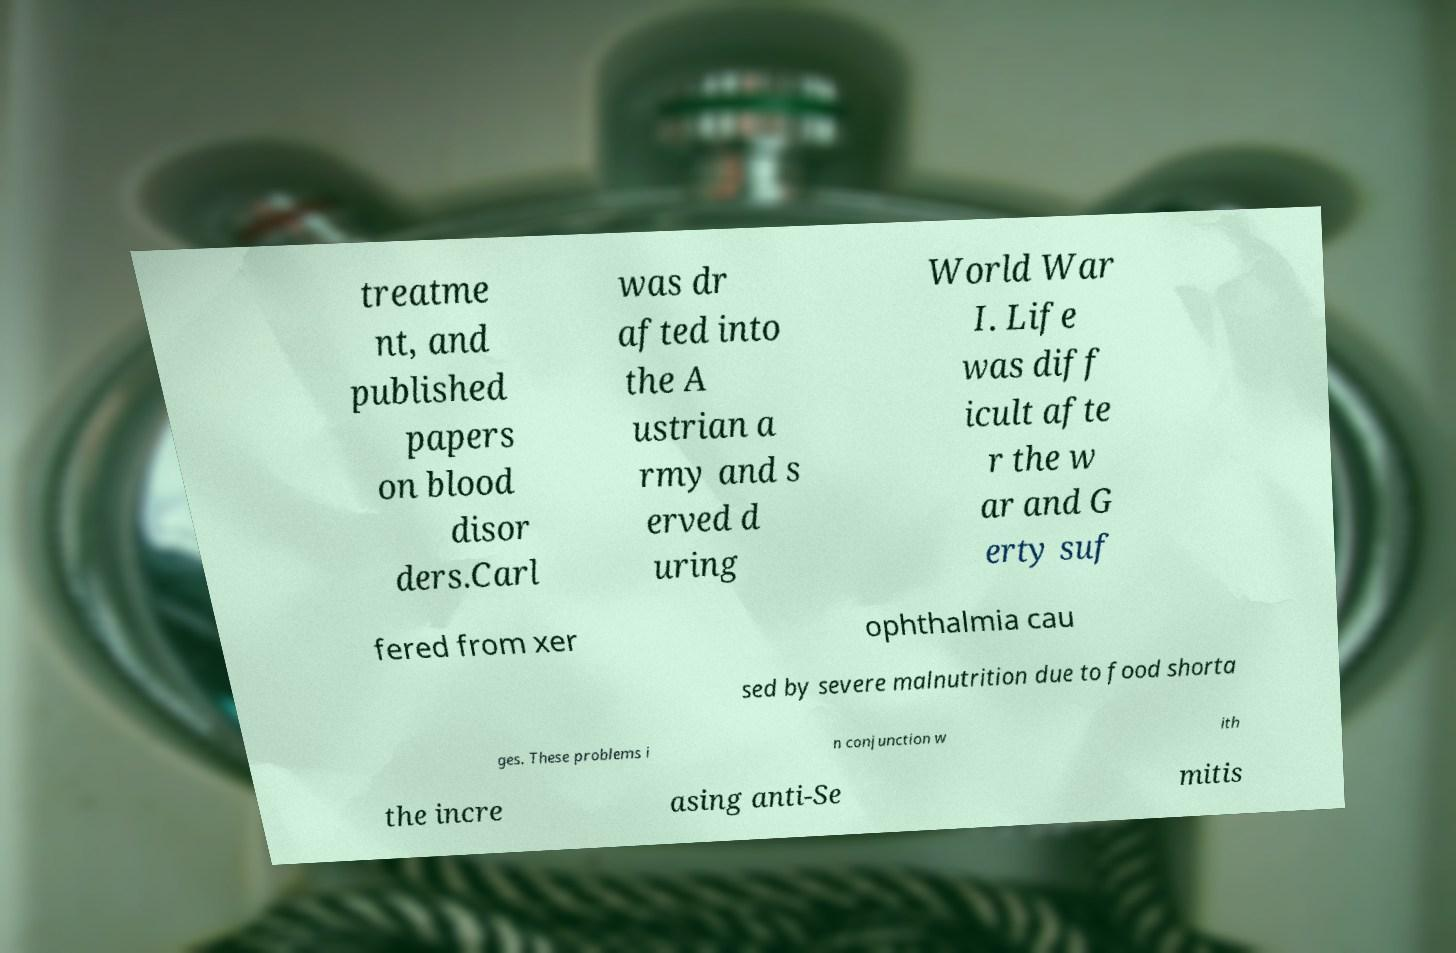Could you assist in decoding the text presented in this image and type it out clearly? treatme nt, and published papers on blood disor ders.Carl was dr afted into the A ustrian a rmy and s erved d uring World War I. Life was diff icult afte r the w ar and G erty suf fered from xer ophthalmia cau sed by severe malnutrition due to food shorta ges. These problems i n conjunction w ith the incre asing anti-Se mitis 